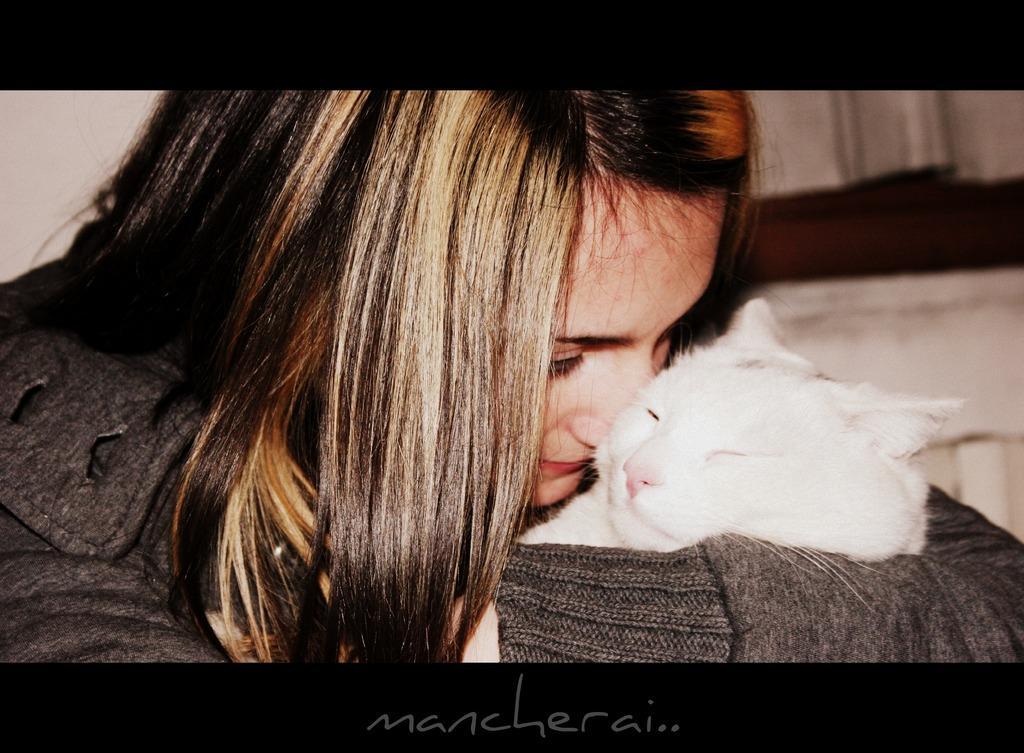Can you describe this image briefly? In this picture there is a woman holding a white cat. This picture seems to be a frame and to the below there is text. In the background there is wall. 